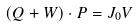Convert formula to latex. <formula><loc_0><loc_0><loc_500><loc_500>( Q + W ) \cdot { P } = J _ { 0 } { V }</formula> 